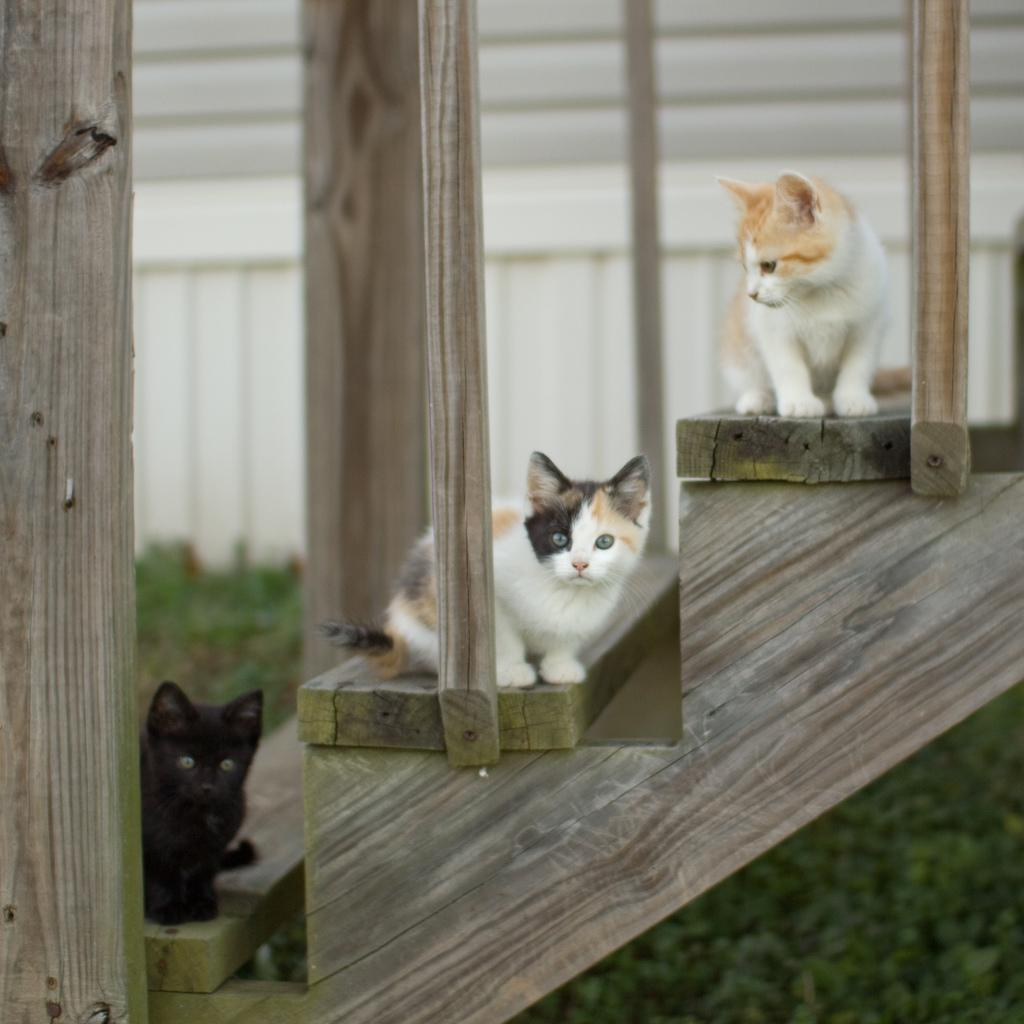What animals can be seen in the image? There are cats in the image. Where are the cats sitting? The cats are sitting on a wood log. What can be seen in the background of the image? There is a wall and ground visible in the background of the image. What type of disease is affecting the cats in the image? There is no indication of any disease affecting the cats in the image. Can you see a car in the image? No, there is no car present in the image. 